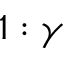Convert formula to latex. <formula><loc_0><loc_0><loc_500><loc_500>1 \colon \gamma</formula> 